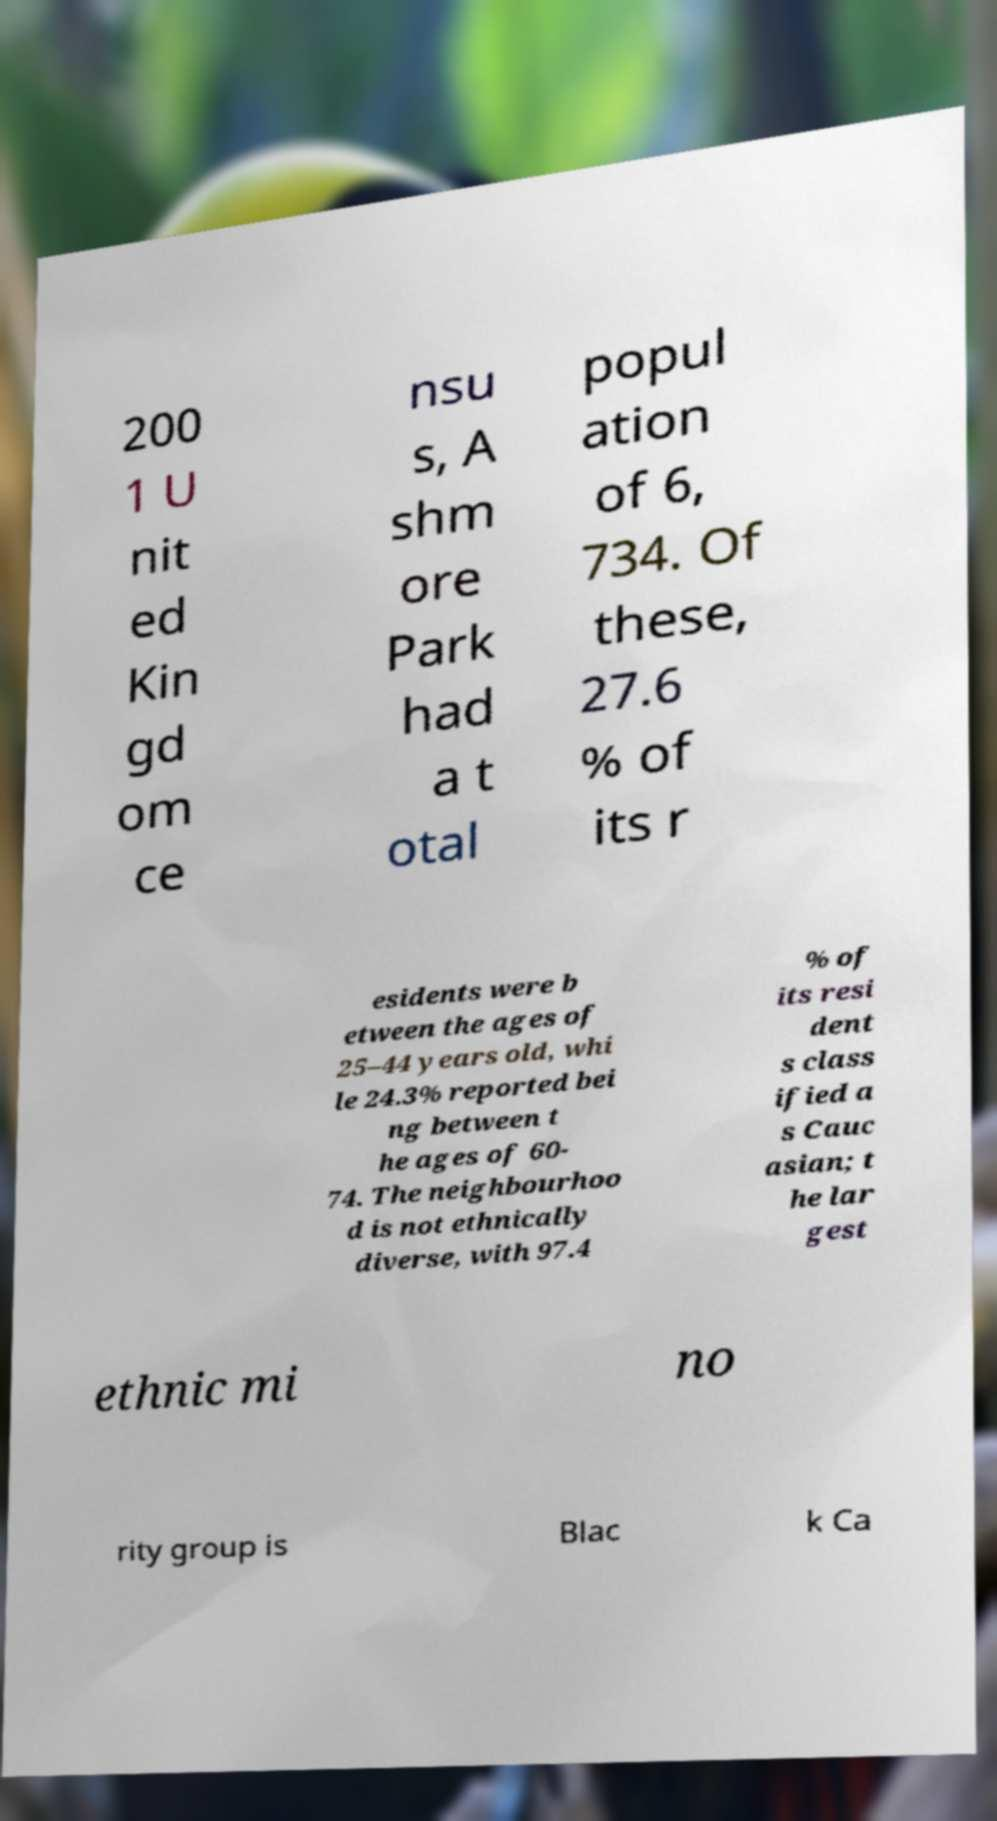Please identify and transcribe the text found in this image. 200 1 U nit ed Kin gd om ce nsu s, A shm ore Park had a t otal popul ation of 6, 734. Of these, 27.6 % of its r esidents were b etween the ages of 25–44 years old, whi le 24.3% reported bei ng between t he ages of 60- 74. The neighbourhoo d is not ethnically diverse, with 97.4 % of its resi dent s class ified a s Cauc asian; t he lar gest ethnic mi no rity group is Blac k Ca 